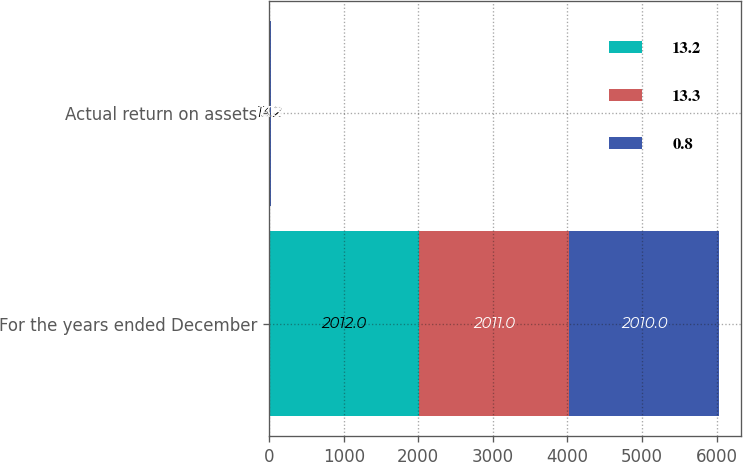<chart> <loc_0><loc_0><loc_500><loc_500><stacked_bar_chart><ecel><fcel>For the years ended December<fcel>Actual return on assets<nl><fcel>13.2<fcel>2012<fcel>13.2<nl><fcel>13.3<fcel>2011<fcel>0.8<nl><fcel>0.8<fcel>2010<fcel>13.3<nl></chart> 